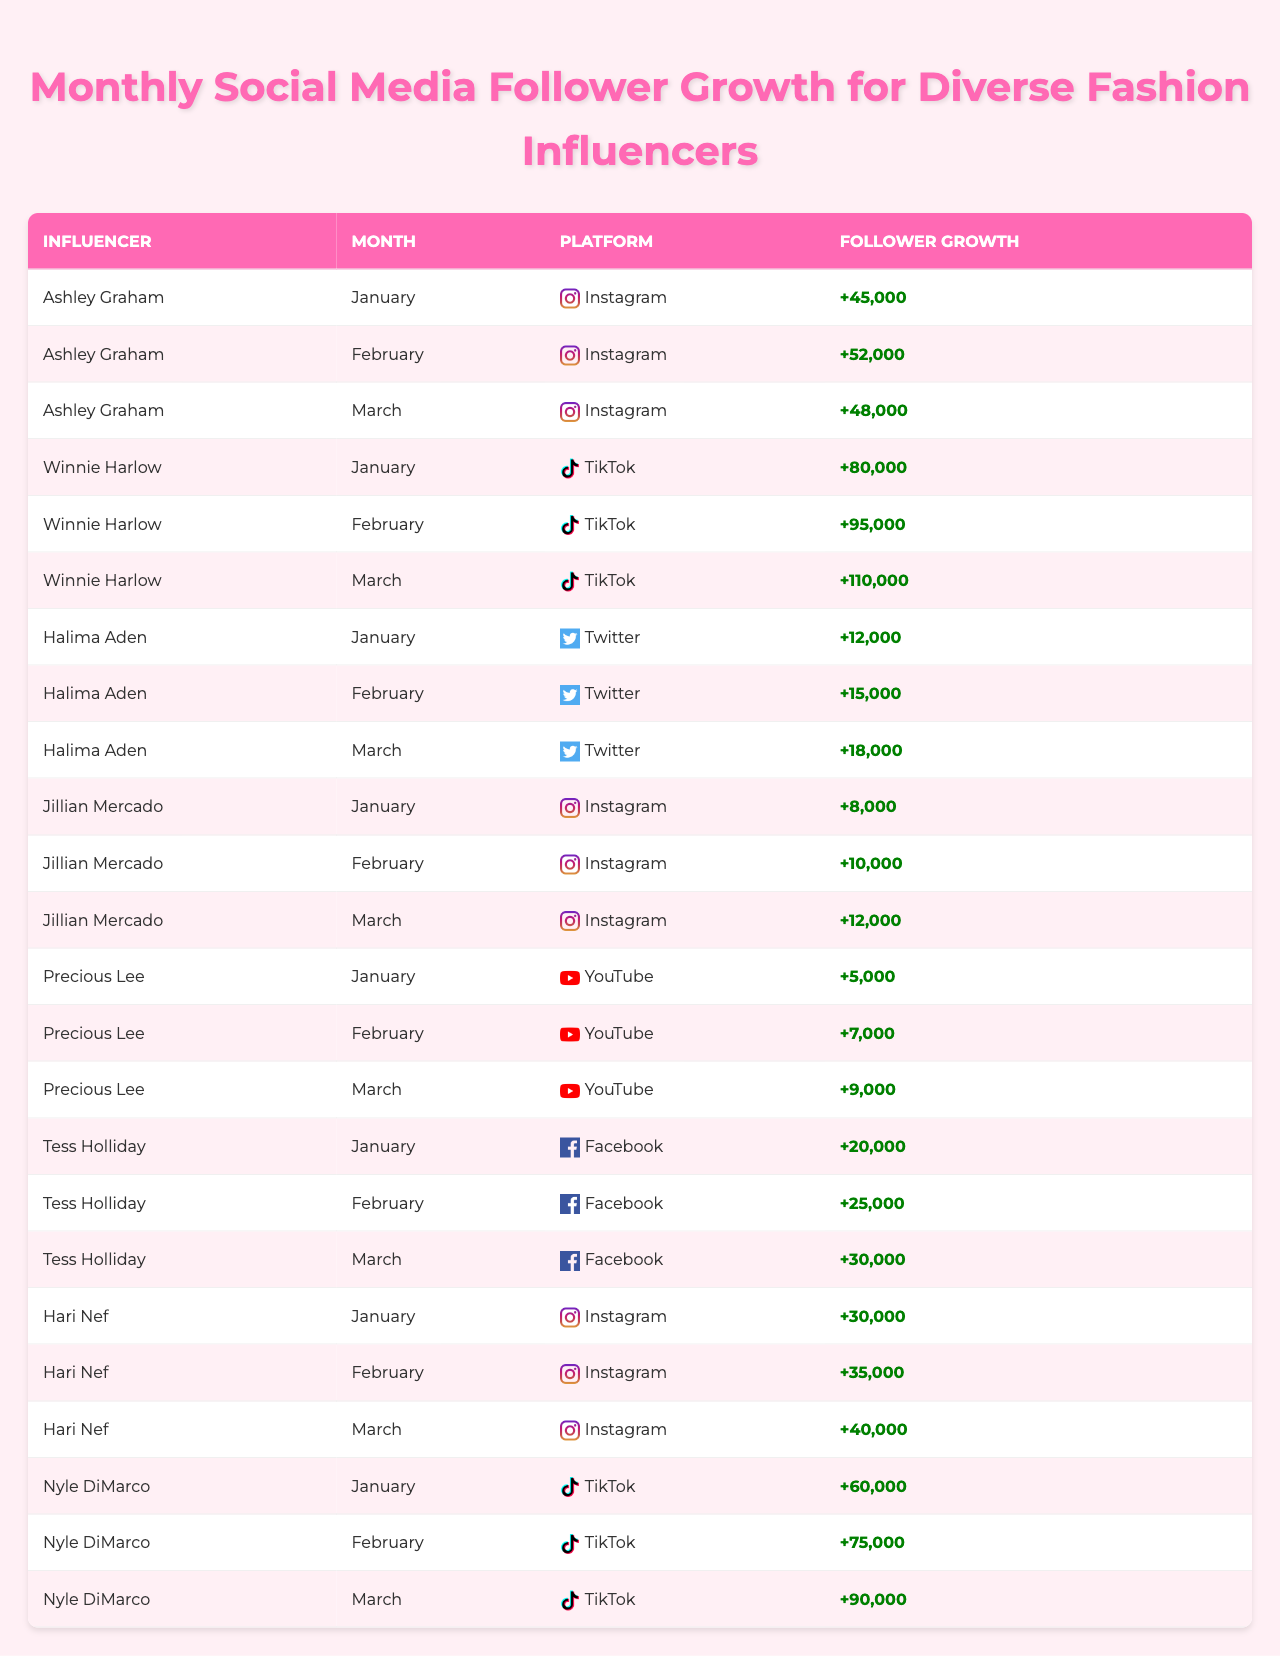What was the total follower growth for Ashley Graham in January, February, and March? To find the total follower growth for Ashley Graham, we add the values from each month: 45,000 (January) + 52,000 (February) + 48,000 (March) = 145,000.
Answer: 145,000 Which platform had the highest follower growth in February? In February, Winnie Harlow had 95,000 followers on TikTok, which is the highest compared to other influencers and platforms listed.
Answer: TikTok Did Halima Aden experience an increase in follower growth every month? Analyzing the data, Halima Aden's follower growth increased each month: 12,000 (January), 15,000 (February), and 18,000 (March), indicating consistent growth.
Answer: Yes What is the average follower growth for Jillian Mercado over the three months? Calculate the average follower growth by summing her growth: 8,000 + 10,000 + 12,000 = 30,000. Then divide by the number of months: 30,000 / 3 = 10,000.
Answer: 10,000 Which influencer had the highest follower growth in March? In March, Winnie Harlow had 110,000 followers on TikTok, which is the highest across all influencers and platforms for that month.
Answer: Winnie Harlow What was the difference in follower growth between Nyle DiMarco in February and Ashley Graham in the same month? Nyle DiMarco gained 75,000 followers in February, while Ashley Graham gained 52,000. The difference is 75,000 - 52,000 = 23,000.
Answer: 23,000 Did Tess Holliday gain more followers in March compared to January? According to the data, Tess Holliday gained 30,000 followers in March and 20,000 in January, indicating an increase.
Answer: Yes What was the total follower growth across all influencers on Instagram in January? For January, Ashley Graham gained 45,000 and Jillian Mercado gained 8,000, totaling 45,000 + 8,000 = 53,000 for Instagram.
Answer: 53,000 Who showed the highest overall follower growth over the three months? To determine the influencer with the highest overall growth, sum each influencer's monthly growth: Winnie Harlow had a total of 95,000 (January) + 110,000 (February) + 110,000 (March), which is the highest total of 300,000.
Answer: Winnie Harlow Which platform was used by the influencer with the lowest follower growth in January? In January, Precious Lee had the lowest growth at 5,000 followers on YouTube.
Answer: YouTube 